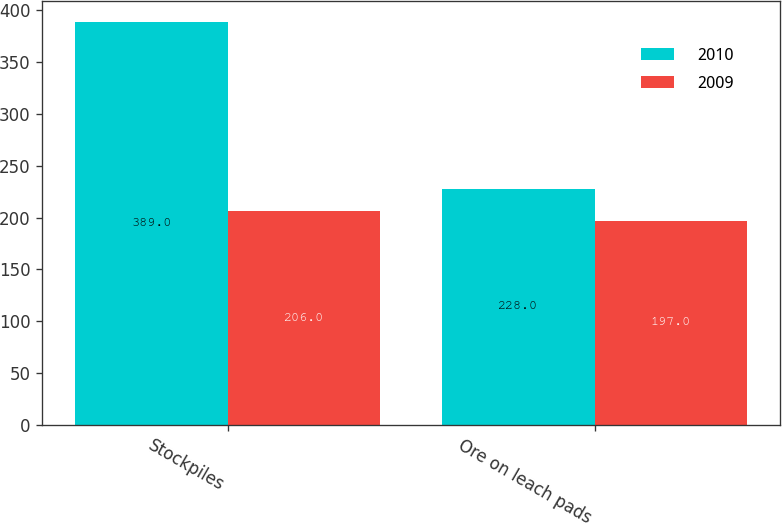<chart> <loc_0><loc_0><loc_500><loc_500><stacked_bar_chart><ecel><fcel>Stockpiles<fcel>Ore on leach pads<nl><fcel>2010<fcel>389<fcel>228<nl><fcel>2009<fcel>206<fcel>197<nl></chart> 